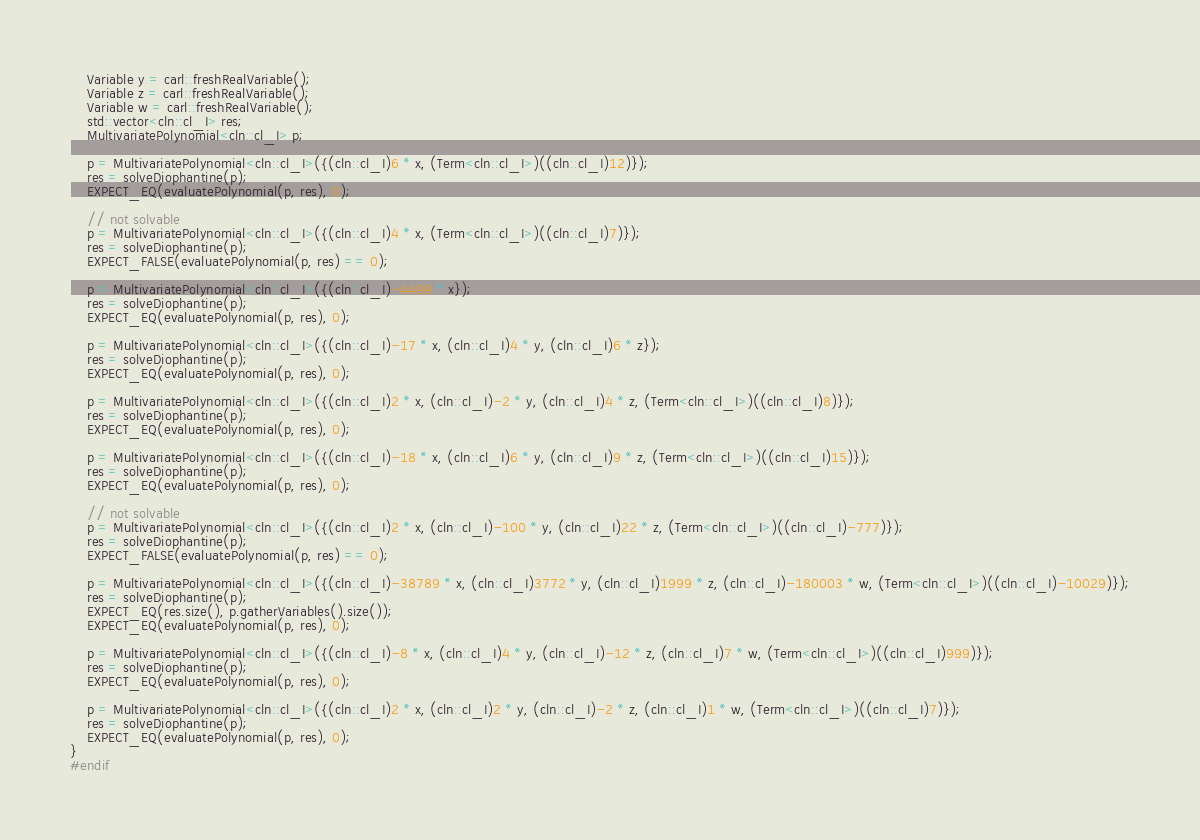<code> <loc_0><loc_0><loc_500><loc_500><_C++_>	Variable y = carl::freshRealVariable();
	Variable z = carl::freshRealVariable();
	Variable w = carl::freshRealVariable();
	std::vector<cln::cl_I> res;
	MultivariatePolynomial<cln::cl_I> p;

	p = MultivariatePolynomial<cln::cl_I>({(cln::cl_I)6 * x, (Term<cln::cl_I>)((cln::cl_I)12)});
	res = solveDiophantine(p);
	EXPECT_EQ(evaluatePolynomial(p, res), 0);

	// not solvable
	p = MultivariatePolynomial<cln::cl_I>({(cln::cl_I)4 * x, (Term<cln::cl_I>)((cln::cl_I)7)});
	res = solveDiophantine(p);
	EXPECT_FALSE(evaluatePolynomial(p, res) == 0);

	p = MultivariatePolynomial<cln::cl_I>({(cln::cl_I)-4499 * x});
	res = solveDiophantine(p);
	EXPECT_EQ(evaluatePolynomial(p, res), 0);

	p = MultivariatePolynomial<cln::cl_I>({(cln::cl_I)-17 * x, (cln::cl_I)4 * y, (cln::cl_I)6 * z});
	res = solveDiophantine(p);
	EXPECT_EQ(evaluatePolynomial(p, res), 0);

	p = MultivariatePolynomial<cln::cl_I>({(cln::cl_I)2 * x, (cln::cl_I)-2 * y, (cln::cl_I)4 * z, (Term<cln::cl_I>)((cln::cl_I)8)});
	res = solveDiophantine(p);
	EXPECT_EQ(evaluatePolynomial(p, res), 0);

	p = MultivariatePolynomial<cln::cl_I>({(cln::cl_I)-18 * x, (cln::cl_I)6 * y, (cln::cl_I)9 * z, (Term<cln::cl_I>)((cln::cl_I)15)});
	res = solveDiophantine(p);
	EXPECT_EQ(evaluatePolynomial(p, res), 0);

	// not solvable
	p = MultivariatePolynomial<cln::cl_I>({(cln::cl_I)2 * x, (cln::cl_I)-100 * y, (cln::cl_I)22 * z, (Term<cln::cl_I>)((cln::cl_I)-777)});
	res = solveDiophantine(p);
	EXPECT_FALSE(evaluatePolynomial(p, res) == 0);

	p = MultivariatePolynomial<cln::cl_I>({(cln::cl_I)-38789 * x, (cln::cl_I)3772 * y, (cln::cl_I)1999 * z, (cln::cl_I)-180003 * w, (Term<cln::cl_I>)((cln::cl_I)-10029)});
	res = solveDiophantine(p);
	EXPECT_EQ(res.size(), p.gatherVariables().size());
	EXPECT_EQ(evaluatePolynomial(p, res), 0);

	p = MultivariatePolynomial<cln::cl_I>({(cln::cl_I)-8 * x, (cln::cl_I)4 * y, (cln::cl_I)-12 * z, (cln::cl_I)7 * w, (Term<cln::cl_I>)((cln::cl_I)999)});
	res = solveDiophantine(p);
	EXPECT_EQ(evaluatePolynomial(p, res), 0);

	p = MultivariatePolynomial<cln::cl_I>({(cln::cl_I)2 * x, (cln::cl_I)2 * y, (cln::cl_I)-2 * z, (cln::cl_I)1 * w, (Term<cln::cl_I>)((cln::cl_I)7)});
	res = solveDiophantine(p);
	EXPECT_EQ(evaluatePolynomial(p, res), 0);
}
#endif
</code> 